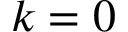Convert formula to latex. <formula><loc_0><loc_0><loc_500><loc_500>k = 0</formula> 